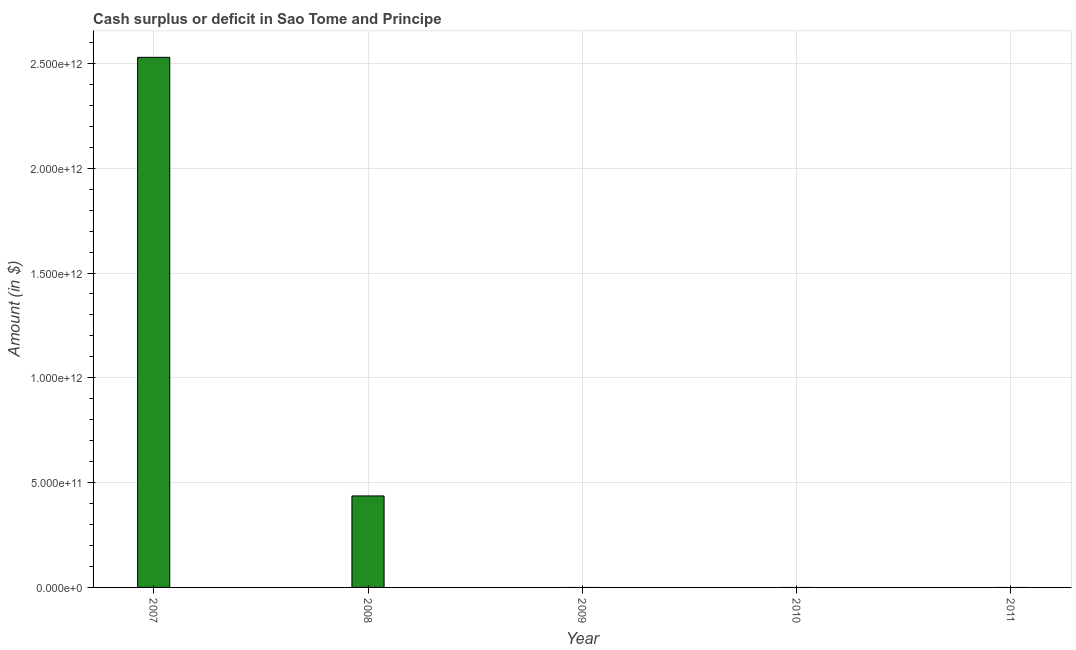Does the graph contain grids?
Offer a terse response. Yes. What is the title of the graph?
Your answer should be very brief. Cash surplus or deficit in Sao Tome and Principe. What is the label or title of the X-axis?
Offer a very short reply. Year. What is the label or title of the Y-axis?
Your answer should be compact. Amount (in $). Across all years, what is the maximum cash surplus or deficit?
Offer a terse response. 2.53e+12. Across all years, what is the minimum cash surplus or deficit?
Offer a terse response. 0. In which year was the cash surplus or deficit maximum?
Offer a very short reply. 2007. What is the sum of the cash surplus or deficit?
Your response must be concise. 2.97e+12. What is the difference between the cash surplus or deficit in 2007 and 2008?
Offer a very short reply. 2.09e+12. What is the average cash surplus or deficit per year?
Your response must be concise. 5.93e+11. What is the ratio of the cash surplus or deficit in 2007 to that in 2008?
Your response must be concise. 5.79. Is the difference between the cash surplus or deficit in 2007 and 2008 greater than the difference between any two years?
Keep it short and to the point. No. What is the difference between the highest and the lowest cash surplus or deficit?
Offer a terse response. 2.53e+12. In how many years, is the cash surplus or deficit greater than the average cash surplus or deficit taken over all years?
Your response must be concise. 1. How many bars are there?
Your answer should be very brief. 2. Are all the bars in the graph horizontal?
Your answer should be compact. No. What is the difference between two consecutive major ticks on the Y-axis?
Ensure brevity in your answer.  5.00e+11. What is the Amount (in $) in 2007?
Your answer should be compact. 2.53e+12. What is the Amount (in $) of 2008?
Keep it short and to the point. 4.36e+11. What is the difference between the Amount (in $) in 2007 and 2008?
Ensure brevity in your answer.  2.09e+12. What is the ratio of the Amount (in $) in 2007 to that in 2008?
Offer a terse response. 5.79. 